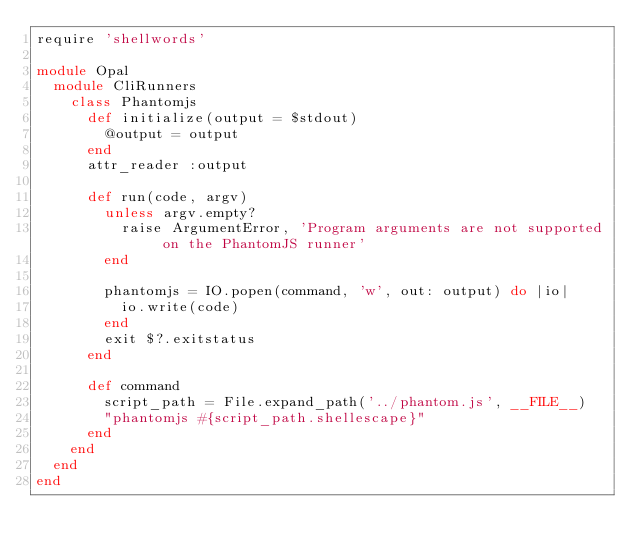<code> <loc_0><loc_0><loc_500><loc_500><_Ruby_>require 'shellwords'

module Opal
  module CliRunners
    class Phantomjs
      def initialize(output = $stdout)
        @output = output
      end
      attr_reader :output

      def run(code, argv)
        unless argv.empty?
          raise ArgumentError, 'Program arguments are not supported on the PhantomJS runner'
        end

        phantomjs = IO.popen(command, 'w', out: output) do |io|
          io.write(code)
        end
        exit $?.exitstatus
      end

      def command
        script_path = File.expand_path('../phantom.js', __FILE__)
        "phantomjs #{script_path.shellescape}"
      end
    end
  end
end
</code> 